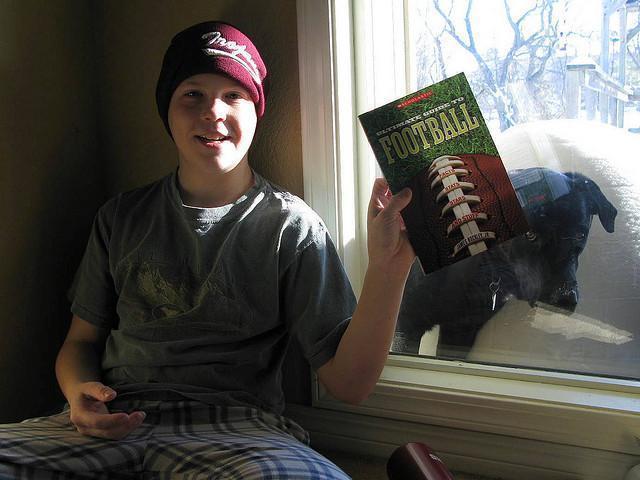How many towels are hanging from the oven door?
Give a very brief answer. 0. 